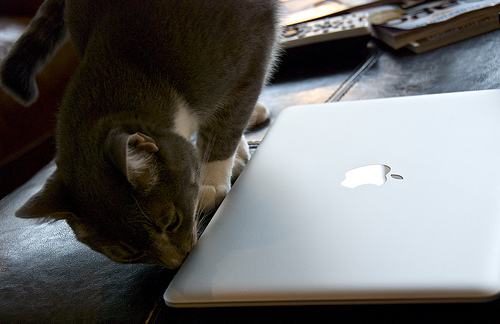What is the cat doing near the laptop? The cat appears to be sniffing or showing interest in the MacBook, a behavior that cats often exhibit out of curiosity towards new or familiar objects in their environment. 